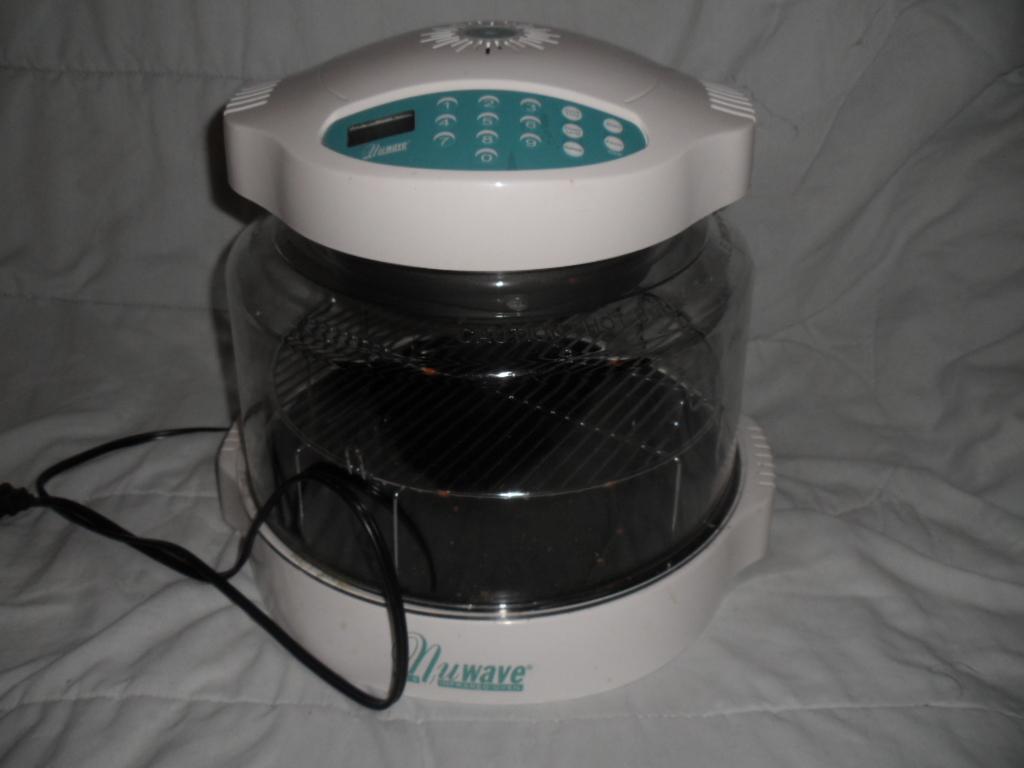What brand is this device?
Ensure brevity in your answer.  Nuwave. What brand is this?
Your response must be concise. Nuwave. 